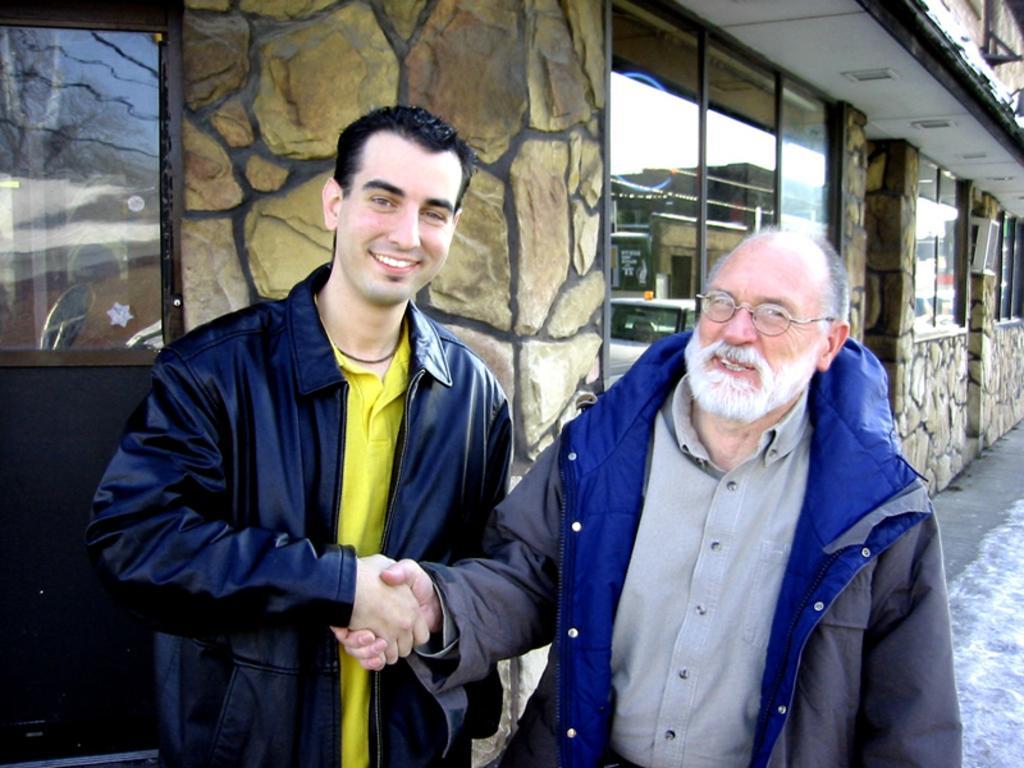Could you give a brief overview of what you see in this image? In this image there are two persons standing in the center and shaking their hands having smile on their faces. In the background there is a building. 